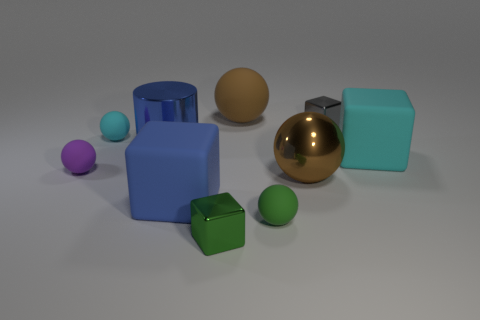Subtract all cyan spheres. How many spheres are left? 4 Subtract all green balls. How many balls are left? 4 Subtract 3 spheres. How many spheres are left? 2 Subtract all blue spheres. Subtract all gray cubes. How many spheres are left? 5 Subtract all cubes. How many objects are left? 6 Subtract 0 red cylinders. How many objects are left? 10 Subtract all large green spheres. Subtract all large blue things. How many objects are left? 8 Add 1 small metallic cubes. How many small metallic cubes are left? 3 Add 2 green blocks. How many green blocks exist? 3 